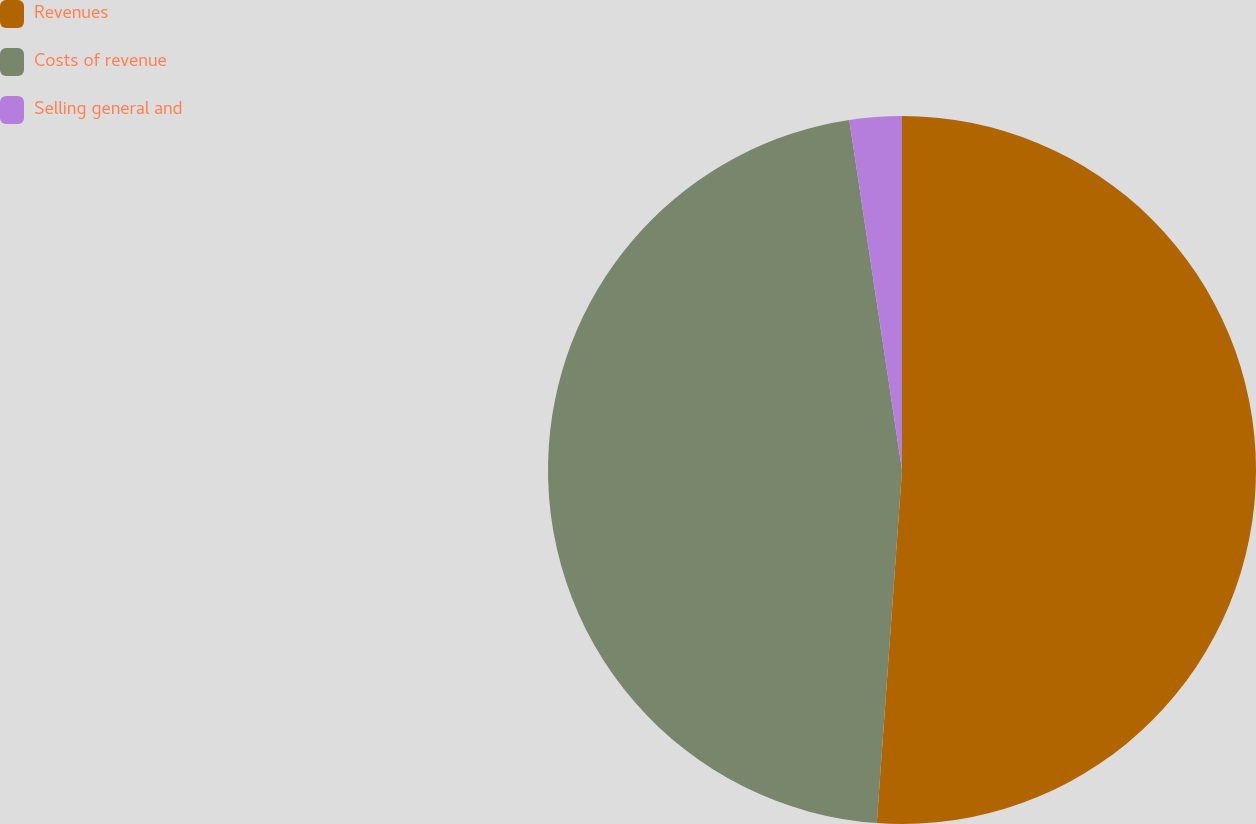<chart> <loc_0><loc_0><loc_500><loc_500><pie_chart><fcel>Revenues<fcel>Costs of revenue<fcel>Selling general and<nl><fcel>51.13%<fcel>46.48%<fcel>2.38%<nl></chart> 